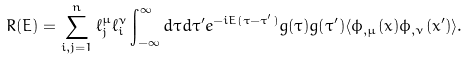Convert formula to latex. <formula><loc_0><loc_0><loc_500><loc_500>R ( E ) = \sum _ { i , j = 1 } ^ { n } { \ell _ { j } ^ { \mu } } { \ell _ { i } ^ { \nu } } \int _ { - \infty } ^ { \infty } d \tau d \tau ^ { \prime } e ^ { - i E ( \tau - \tau ^ { \prime } ) } g ( \tau ) g ( \tau ^ { \prime } ) \langle \phi _ { , \mu } ( x ) \phi _ { , \nu } ( x ^ { \prime } ) \rangle .</formula> 